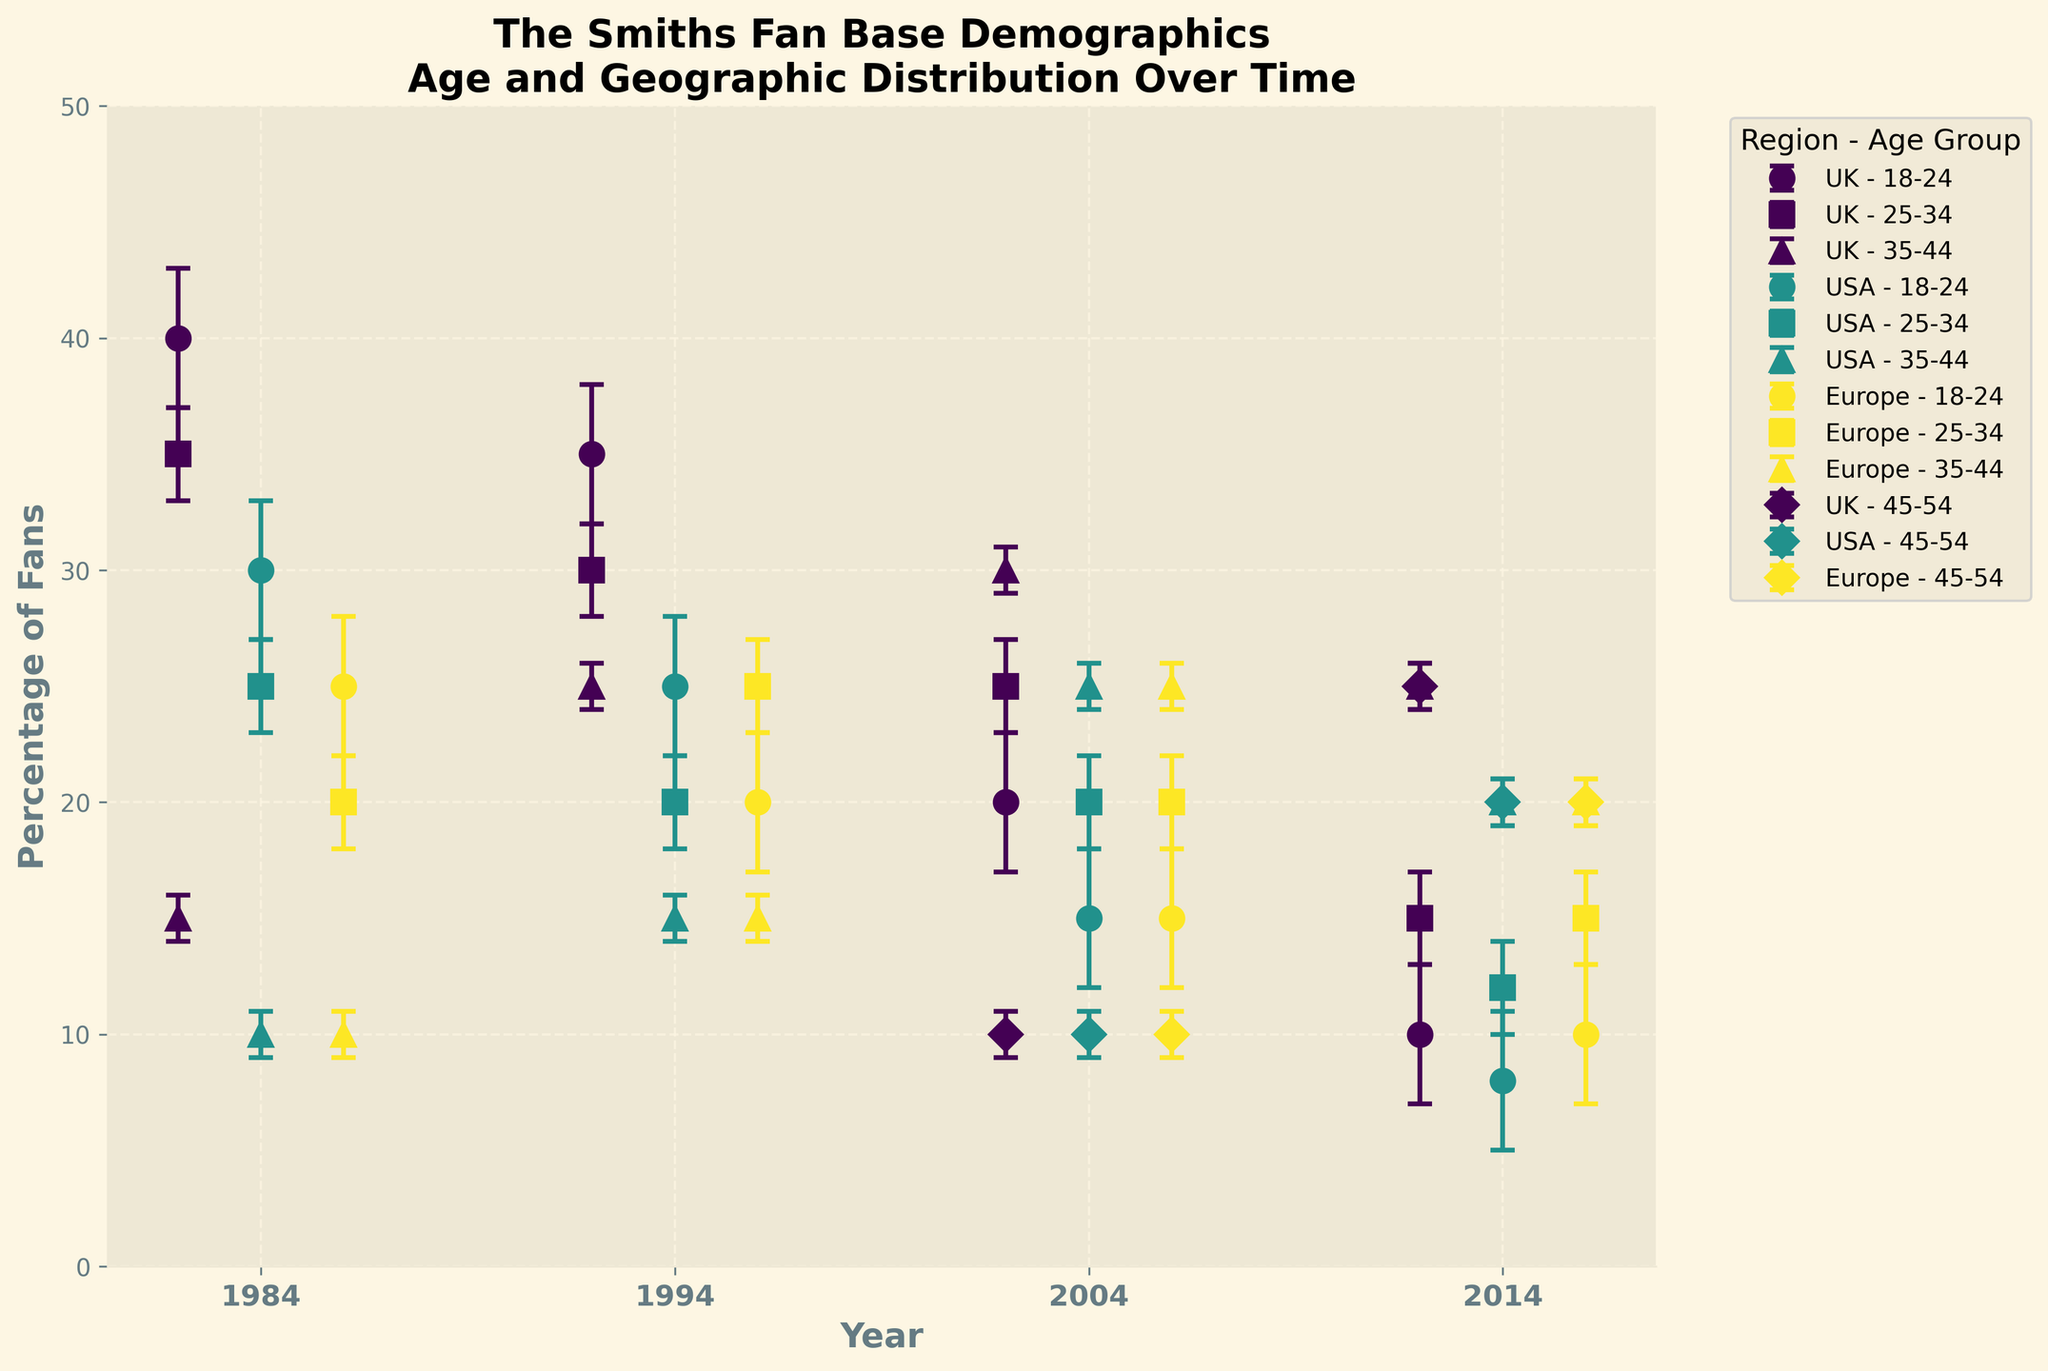What is the title of the figure? The title of the figure is displayed at the top and usually describes what the figure is about. Looking at the top of the graph, it states: "The Smiths Fan Base Demographics: Age and Geographic Distribution Over Time".
Answer: The Smiths Fan Base Demographics: Age and Geographic Distribution Over Time What are the age groups represented in the figure? The age groups are indicated by different markers (like circles, squares, etc.) on the plot. Scanning across the different markers, the age groups represented are 18-24, 25-34, 35-44, and 45-54.
Answer: 18-24, 25-34, 35-44, 45-54 Which year has the highest overall fan percentage in the UK? Look for the highest data points along the y-axis for the UK across different years. In 1984, the 18-24 age group in the UK has a fan percentage of 40%, higher than any other year.
Answer: 1984 How does the percentage of USA fans aged 25-34 in 1984 compare to 1994? Identify the data points for the 25-34 age group in the USA for both 1984 and 1994. In the plot, 1984 shows 25% and 1994 shows 20%. Thus, 1984 has a higher percentage.
Answer: Higher in 1984 What is the trend in the percentage of fans aged 18-24 in the UK from 1984 to 2014? Follow the markers for the 18-24 age group in the UK across the years 1984, 1994, 2004, and 2014. The data points indicate a decrease from 40% in 1984 to 35% in 1994, then to 20% in 2004, and finally to 10% in 2014.
Answer: Decreasing trend Which geographic region shows a consistent increase in the percentage of fans aged 35-44 from 1984 to 2014? Examine the markers for the 35-44 age group across the regions UK, USA, and Europe from 1984 to 2014. In the UK, the percentage increases consistently from 15% (1984), 25% (1994), 30% (2004), to 25% (2014).
Answer: UK Are the error bars longer in 1984 or 2014 for all regions? Compare the lengths of the error bars associated with data points in 1984 and 2014. On average, the error bars in 1984 are generally longer than those in 2014.
Answer: 1984 Which age group in the USA had the largest increase in fan percentage from 2004 to 2014? Identify the data points for age groups in the USA for 2004 and 2014. The group 45-54 increases from 10% in 2004 to 20% in 2014.
Answer: 45-54 Which age group had the lowest percentage of fans in Europe in 2004? Look at the markers for the different age groups in Europe in 2004. The group aged 45-54 has the lowest percentage at 10%.
Answer: 45-54 What is the standard deviation of the percentage of UK fans aged 25-34 in 1994 and 2004? Since the error bars represent the error or standard deviation, check the error bar lengths for the UK for the 25-34 age group in 1994 and 2004. Both years have an error of 2%.
Answer: 2% (both years) 